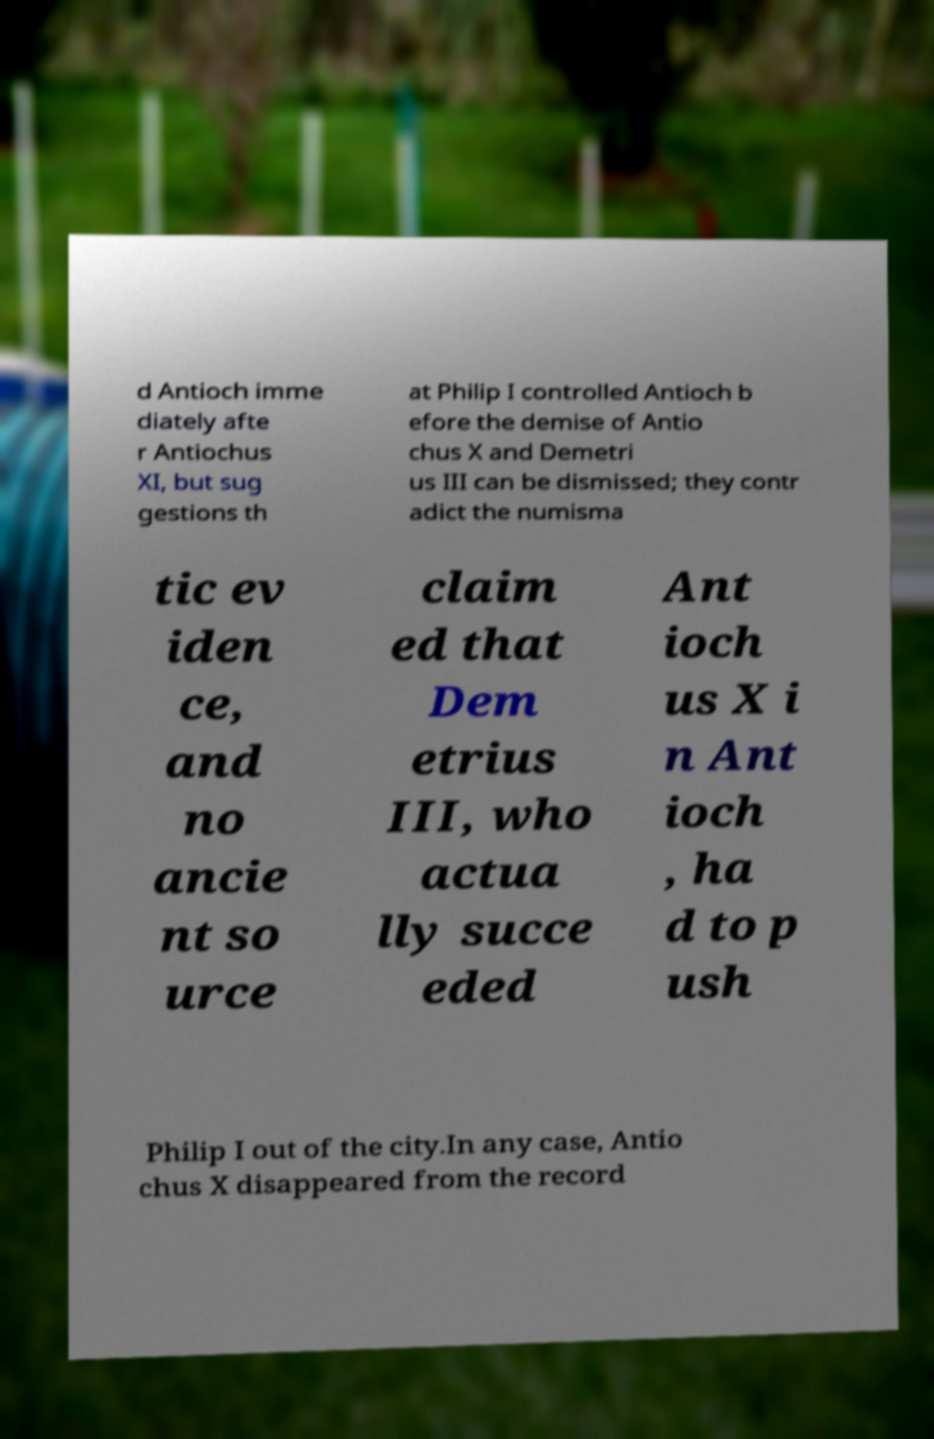What messages or text are displayed in this image? I need them in a readable, typed format. d Antioch imme diately afte r Antiochus XI, but sug gestions th at Philip I controlled Antioch b efore the demise of Antio chus X and Demetri us III can be dismissed; they contr adict the numisma tic ev iden ce, and no ancie nt so urce claim ed that Dem etrius III, who actua lly succe eded Ant ioch us X i n Ant ioch , ha d to p ush Philip I out of the city.In any case, Antio chus X disappeared from the record 